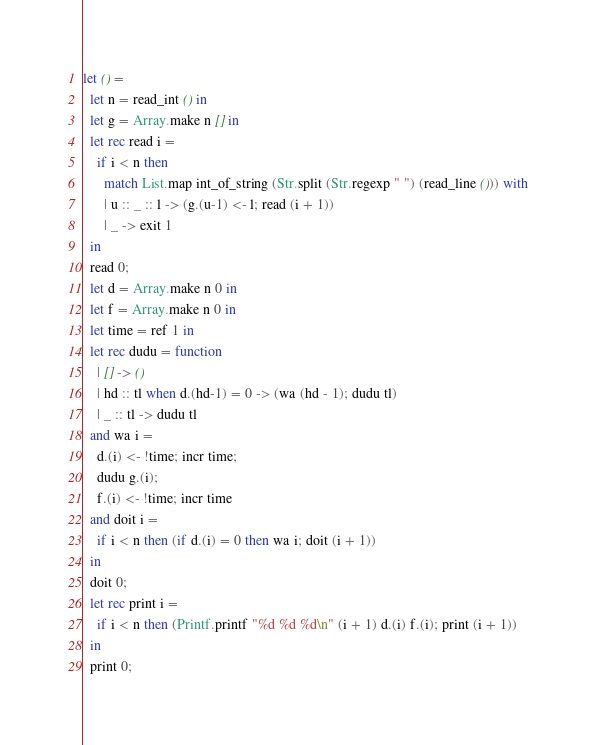Convert code to text. <code><loc_0><loc_0><loc_500><loc_500><_OCaml_>let () =
  let n = read_int () in
  let g = Array.make n [] in
  let rec read i =
    if i < n then
      match List.map int_of_string (Str.split (Str.regexp " ") (read_line ())) with
      | u :: _ :: l -> (g.(u-1) <- l; read (i + 1))
      | _ -> exit 1
  in
  read 0;
  let d = Array.make n 0 in
  let f = Array.make n 0 in
  let time = ref 1 in
  let rec dudu = function
    | [] -> ()
    | hd :: tl when d.(hd-1) = 0 -> (wa (hd - 1); dudu tl)
    | _ :: tl -> dudu tl
  and wa i =
    d.(i) <- !time; incr time;
    dudu g.(i);
    f.(i) <- !time; incr time
  and doit i =
    if i < n then (if d.(i) = 0 then wa i; doit (i + 1))
  in
  doit 0;
  let rec print i =
    if i < n then (Printf.printf "%d %d %d\n" (i + 1) d.(i) f.(i); print (i + 1))
  in
  print 0;</code> 